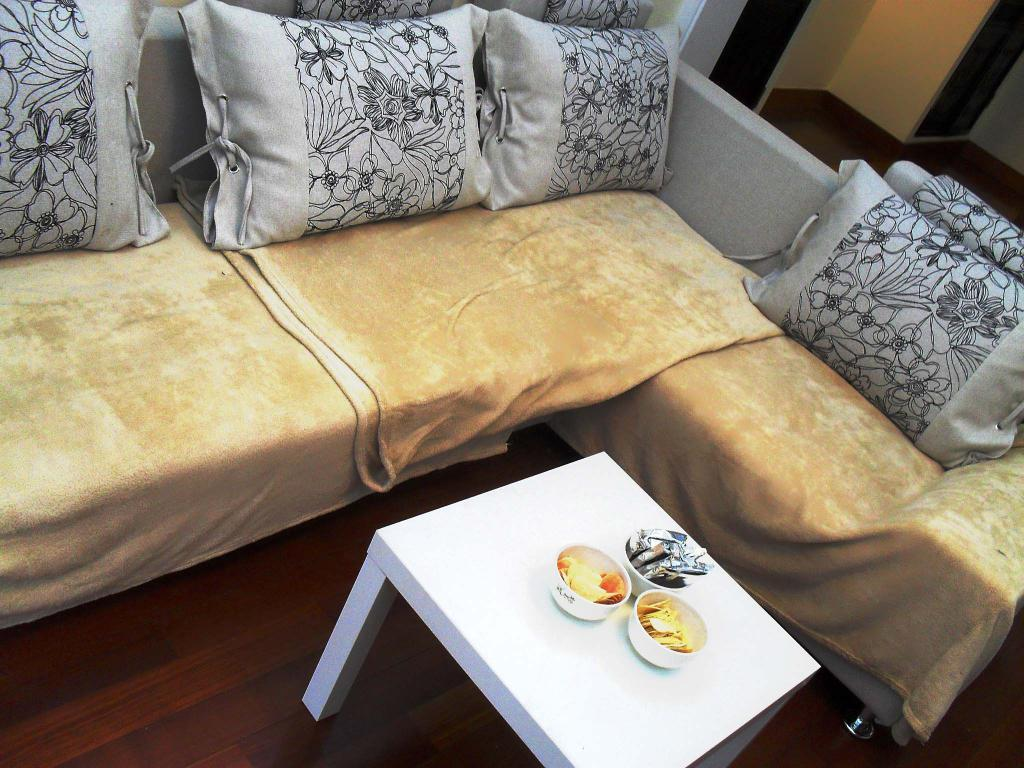What is the main piece of furniture in the image? There is a table in the image. Where is the table located? The table is on the floor. What can be found on top of the table? There are bowls and other objects on the table. What can be seen in the background of the image? There is a sofa, pillows, clothes, and a wall in the background of the image. How many spiders are crawling on the calendar in the image? There is no calendar or spiders present in the image. What is the cause of the clothes being on the wall in the image? There are no clothes on the wall in the image, and no cause can be determined for an event that is not present. 